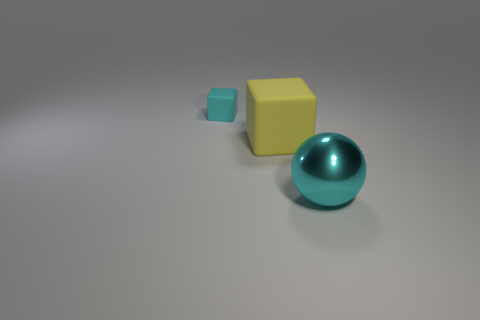How would you describe the lighting in the scene? The lighting in the image appears diffused and soft, likely from an overhead source. This creates subtle shadows directly below the objects, giving them a gentle three-dimensional effect on the otherwise flat surface. 